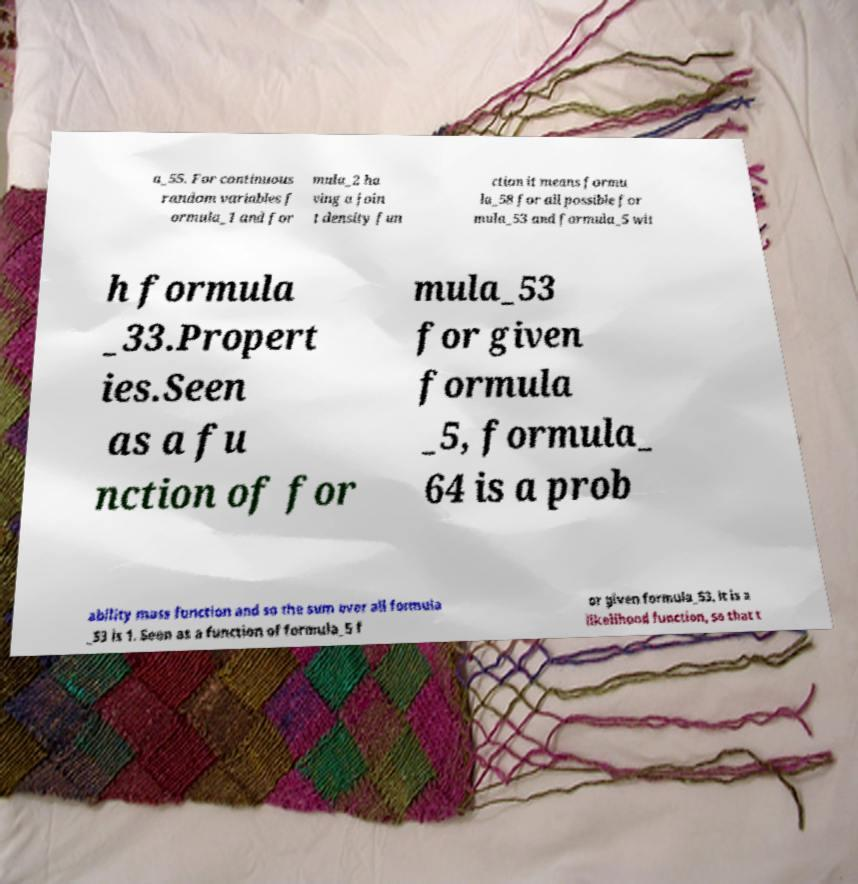Could you assist in decoding the text presented in this image and type it out clearly? a_55. For continuous random variables f ormula_1 and for mula_2 ha ving a join t density fun ction it means formu la_58 for all possible for mula_53 and formula_5 wit h formula _33.Propert ies.Seen as a fu nction of for mula_53 for given formula _5, formula_ 64 is a prob ability mass function and so the sum over all formula _53 is 1. Seen as a function of formula_5 f or given formula_53, it is a likelihood function, so that t 